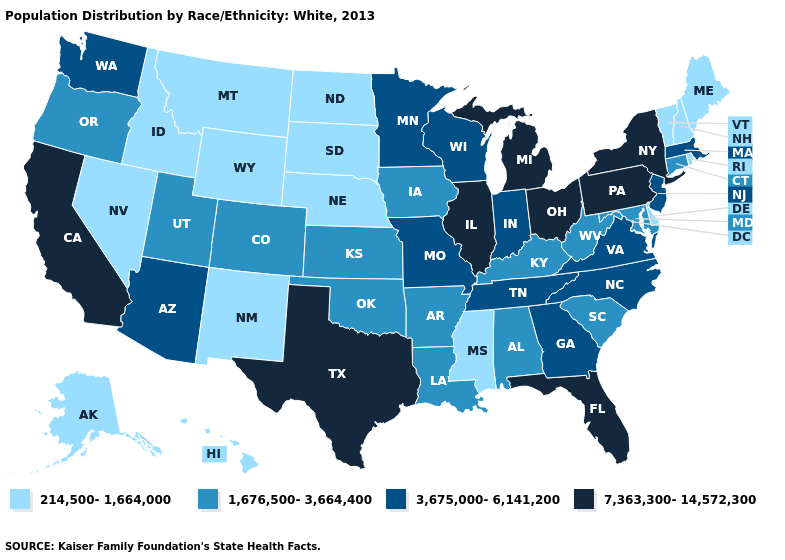What is the value of Vermont?
Answer briefly. 214,500-1,664,000. What is the value of Montana?
Short answer required. 214,500-1,664,000. How many symbols are there in the legend?
Keep it brief. 4. What is the value of Connecticut?
Quick response, please. 1,676,500-3,664,400. Does Iowa have the highest value in the MidWest?
Be succinct. No. Does Texas have the highest value in the USA?
Write a very short answer. Yes. Is the legend a continuous bar?
Be succinct. No. What is the lowest value in states that border Oklahoma?
Short answer required. 214,500-1,664,000. How many symbols are there in the legend?
Write a very short answer. 4. Name the states that have a value in the range 214,500-1,664,000?
Give a very brief answer. Alaska, Delaware, Hawaii, Idaho, Maine, Mississippi, Montana, Nebraska, Nevada, New Hampshire, New Mexico, North Dakota, Rhode Island, South Dakota, Vermont, Wyoming. Name the states that have a value in the range 7,363,300-14,572,300?
Concise answer only. California, Florida, Illinois, Michigan, New York, Ohio, Pennsylvania, Texas. Among the states that border Wyoming , does Nebraska have the lowest value?
Quick response, please. Yes. Does the map have missing data?
Answer briefly. No. Which states have the highest value in the USA?
Concise answer only. California, Florida, Illinois, Michigan, New York, Ohio, Pennsylvania, Texas. Name the states that have a value in the range 1,676,500-3,664,400?
Keep it brief. Alabama, Arkansas, Colorado, Connecticut, Iowa, Kansas, Kentucky, Louisiana, Maryland, Oklahoma, Oregon, South Carolina, Utah, West Virginia. 